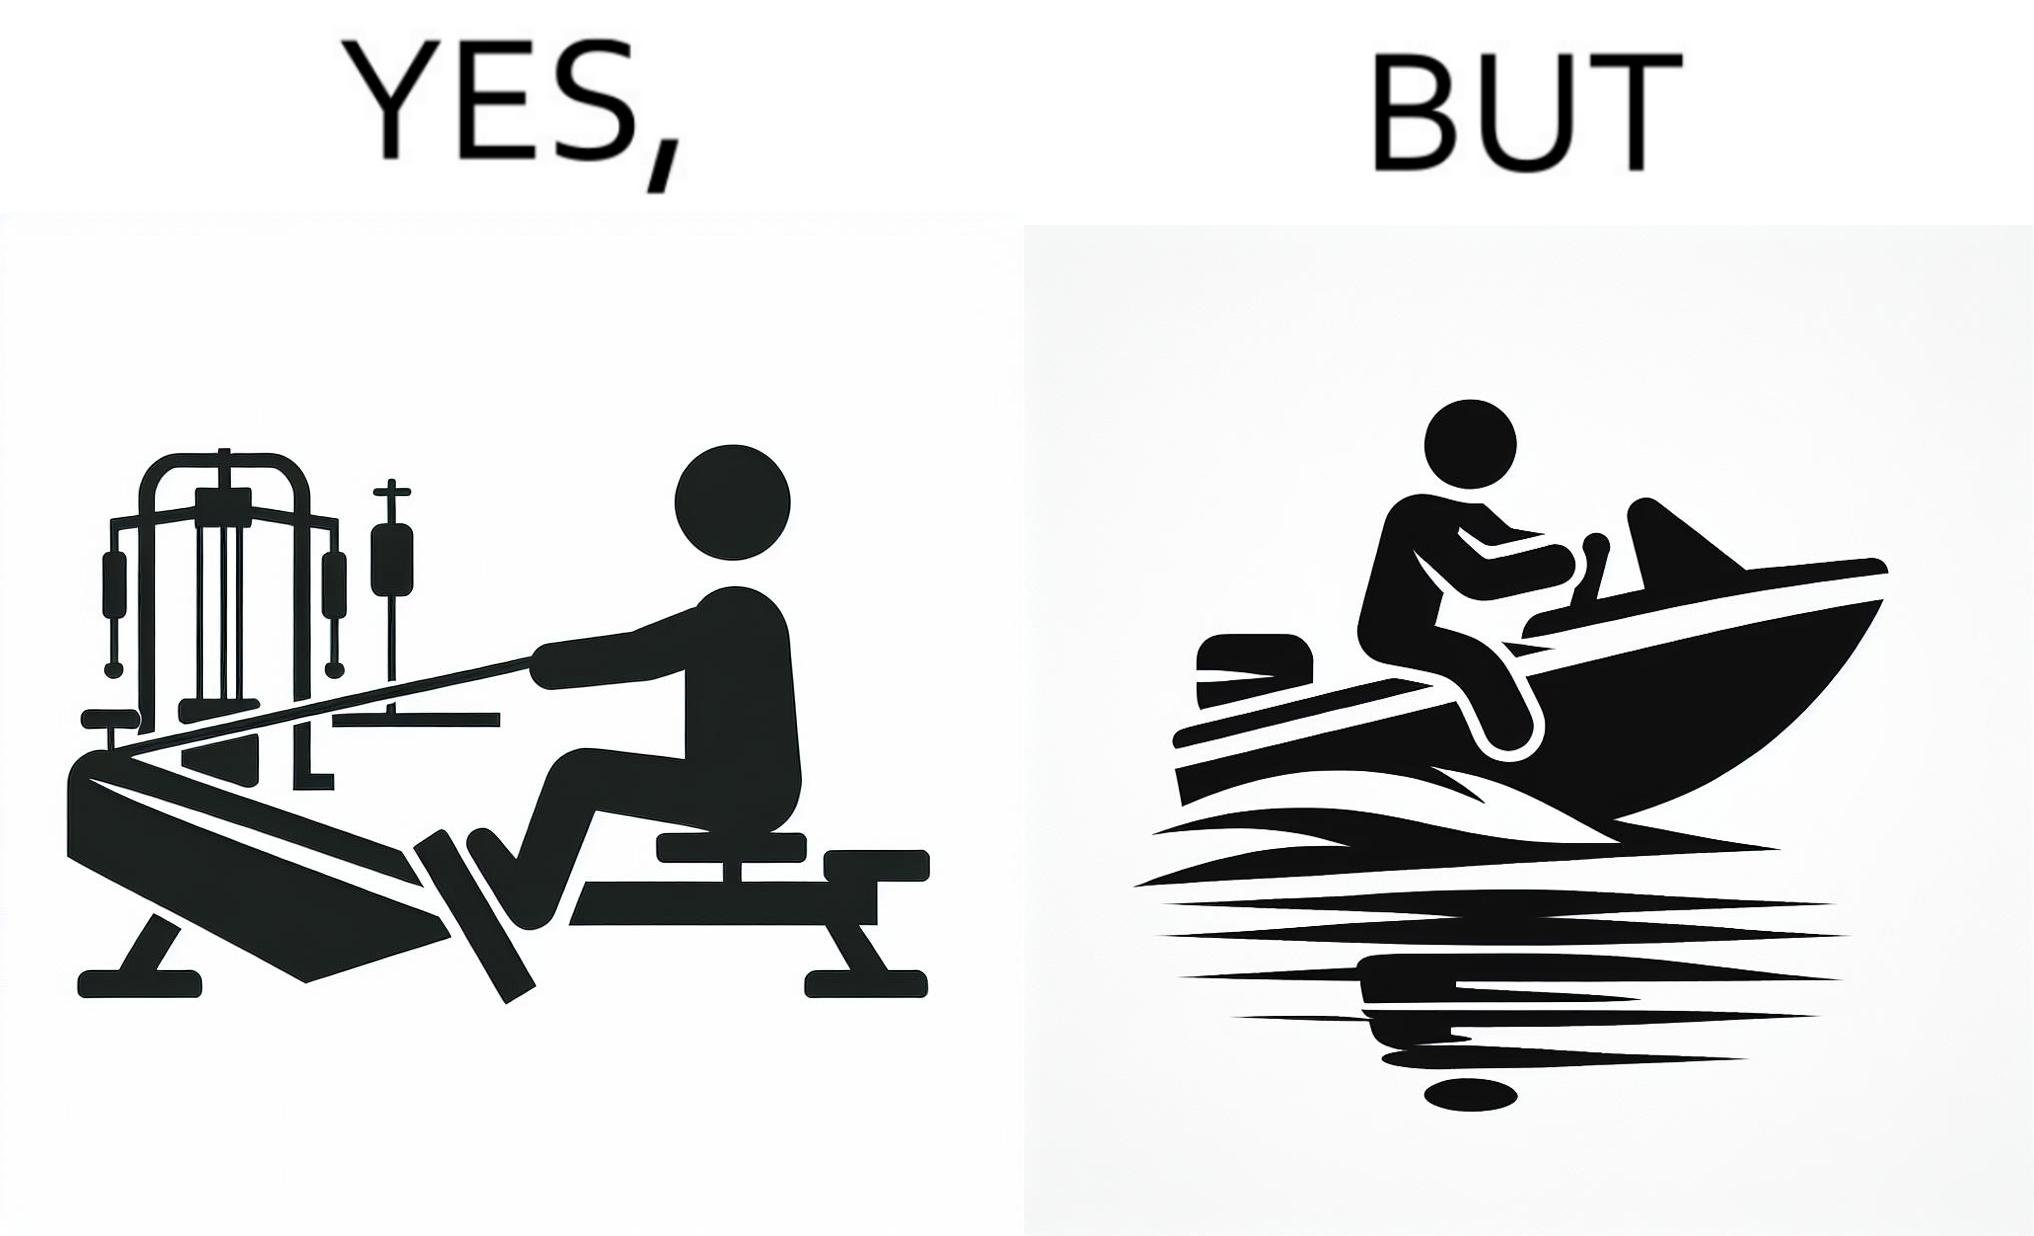What makes this image funny or satirical? The image is ironic, because people often use rowing machine at the gym don't prefer rowing when it comes to boats 